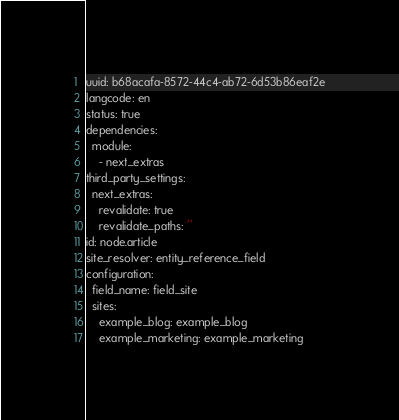Convert code to text. <code><loc_0><loc_0><loc_500><loc_500><_YAML_>uuid: b68acafa-8572-44c4-ab72-6d53b86eaf2e
langcode: en
status: true
dependencies:
  module:
    - next_extras
third_party_settings:
  next_extras:
    revalidate: true
    revalidate_paths: ''
id: node.article
site_resolver: entity_reference_field
configuration:
  field_name: field_site
  sites:
    example_blog: example_blog
    example_marketing: example_marketing
</code> 